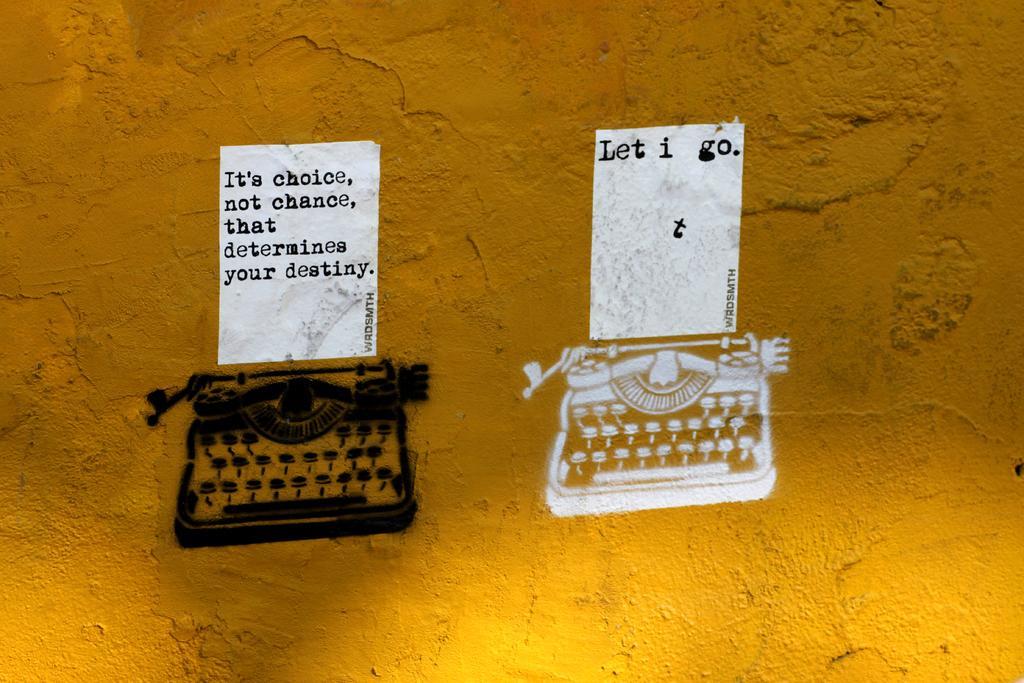How would you summarize this image in a sentence or two? In this picture, we see a yellow wall on which two white posters are pasted. We see some text written on the posters. Below that, we see the drawings in the black and white color are drawn on the yellow wall. 